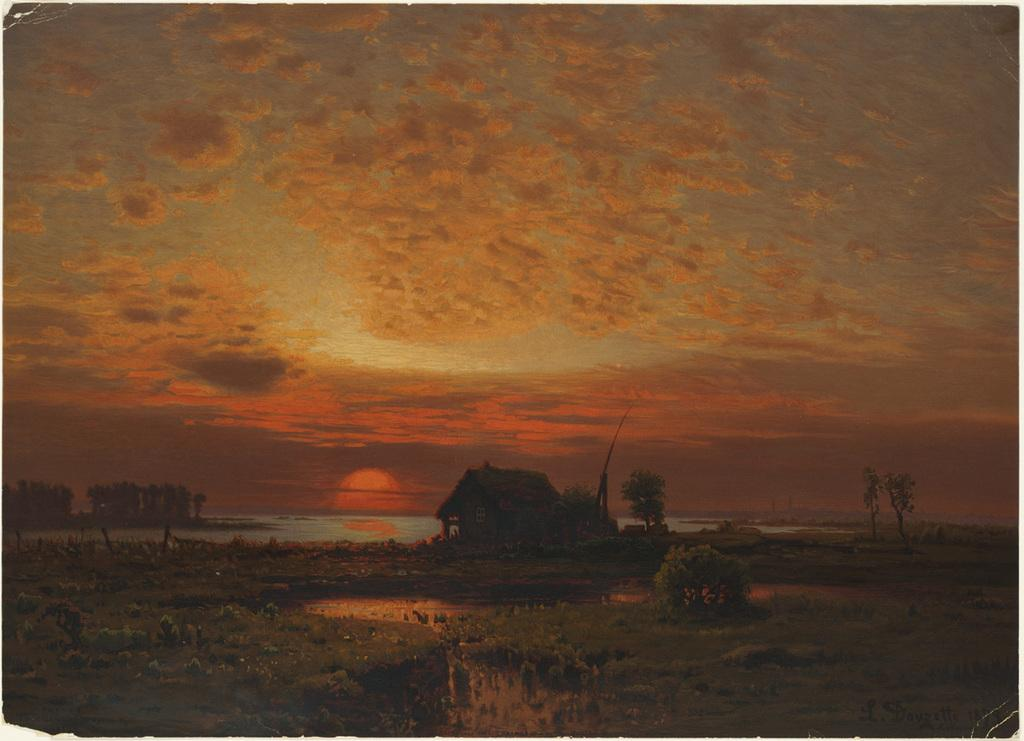What type of terrain is visible in the image? There is grass on the ground in the image. What natural element can be seen besides the grass? There is water visible in the image. What type of structure is present in the image? There is a house in the image. What other natural elements can be seen in the image? There are trees in the image. What is visible in the sky in the image? The sky is visible in the image, and clouds are present. What time of day is depicted in the image? The sun is setting in the image. Can you see the boy attempting to kiss the lip in the image? There is no boy or lip present in the image. 